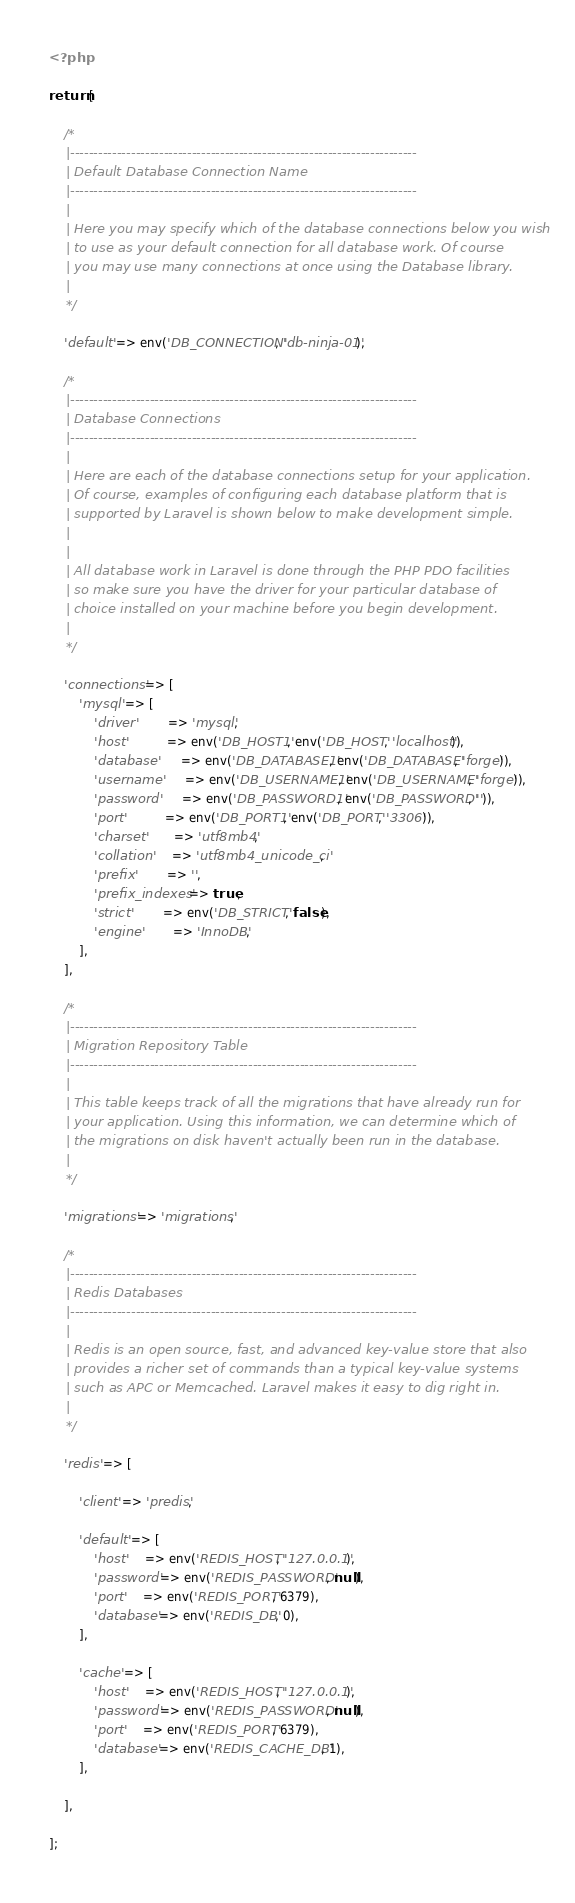Convert code to text. <code><loc_0><loc_0><loc_500><loc_500><_PHP_><?php

return [

    /*
    |--------------------------------------------------------------------------
    | Default Database Connection Name
    |--------------------------------------------------------------------------
    |
    | Here you may specify which of the database connections below you wish
    | to use as your default connection for all database work. Of course
    | you may use many connections at once using the Database library.
    |
    */

    'default' => env('DB_CONNECTION', 'db-ninja-01'),

    /*
    |--------------------------------------------------------------------------
    | Database Connections
    |--------------------------------------------------------------------------
    |
    | Here are each of the database connections setup for your application.
    | Of course, examples of configuring each database platform that is
    | supported by Laravel is shown below to make development simple.
    |
    |
    | All database work in Laravel is done through the PHP PDO facilities
    | so make sure you have the driver for your particular database of
    | choice installed on your machine before you begin development.
    |
    */

    'connections' => [
        'mysql' => [
            'driver'         => 'mysql',
            'host'           => env('DB_HOST1', env('DB_HOST', 'localhost')),
            'database'       => env('DB_DATABASE1', env('DB_DATABASE', 'forge')),
            'username'       => env('DB_USERNAME1', env('DB_USERNAME', 'forge')),
            'password'       => env('DB_PASSWORD1', env('DB_PASSWORD', '')),
            'port'           => env('DB_PORT1', env('DB_PORT', '3306')),
            'charset'        => 'utf8mb4',
            'collation'      => 'utf8mb4_unicode_ci',
            'prefix'         => '',
            'prefix_indexes' => true,
            'strict'         => env('DB_STRICT', false),
            'engine'         => 'InnoDB',
        ],
    ],

    /*
    |--------------------------------------------------------------------------
    | Migration Repository Table
    |--------------------------------------------------------------------------
    |
    | This table keeps track of all the migrations that have already run for
    | your application. Using this information, we can determine which of
    | the migrations on disk haven't actually been run in the database.
    |
    */

    'migrations' => 'migrations',

    /*
    |--------------------------------------------------------------------------
    | Redis Databases
    |--------------------------------------------------------------------------
    |
    | Redis is an open source, fast, and advanced key-value store that also
    | provides a richer set of commands than a typical key-value systems
    | such as APC or Memcached. Laravel makes it easy to dig right in.
    |
    */

    'redis' => [

        'client' => 'predis',

        'default' => [
            'host'     => env('REDIS_HOST', '127.0.0.1'),
            'password' => env('REDIS_PASSWORD', null),
            'port'     => env('REDIS_PORT', 6379),
            'database' => env('REDIS_DB', 0),
        ],

        'cache' => [
            'host'     => env('REDIS_HOST', '127.0.0.1'),
            'password' => env('REDIS_PASSWORD', null),
            'port'     => env('REDIS_PORT', 6379),
            'database' => env('REDIS_CACHE_DB', 1),
        ],

    ],

];
</code> 